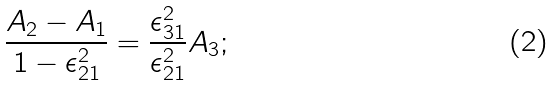<formula> <loc_0><loc_0><loc_500><loc_500>\frac { A _ { 2 } - A _ { 1 } } { 1 - \epsilon _ { 2 1 } ^ { 2 } } = \frac { \epsilon _ { 3 1 } ^ { 2 } } { \epsilon _ { 2 1 } ^ { 2 } } A _ { 3 } ;</formula> 